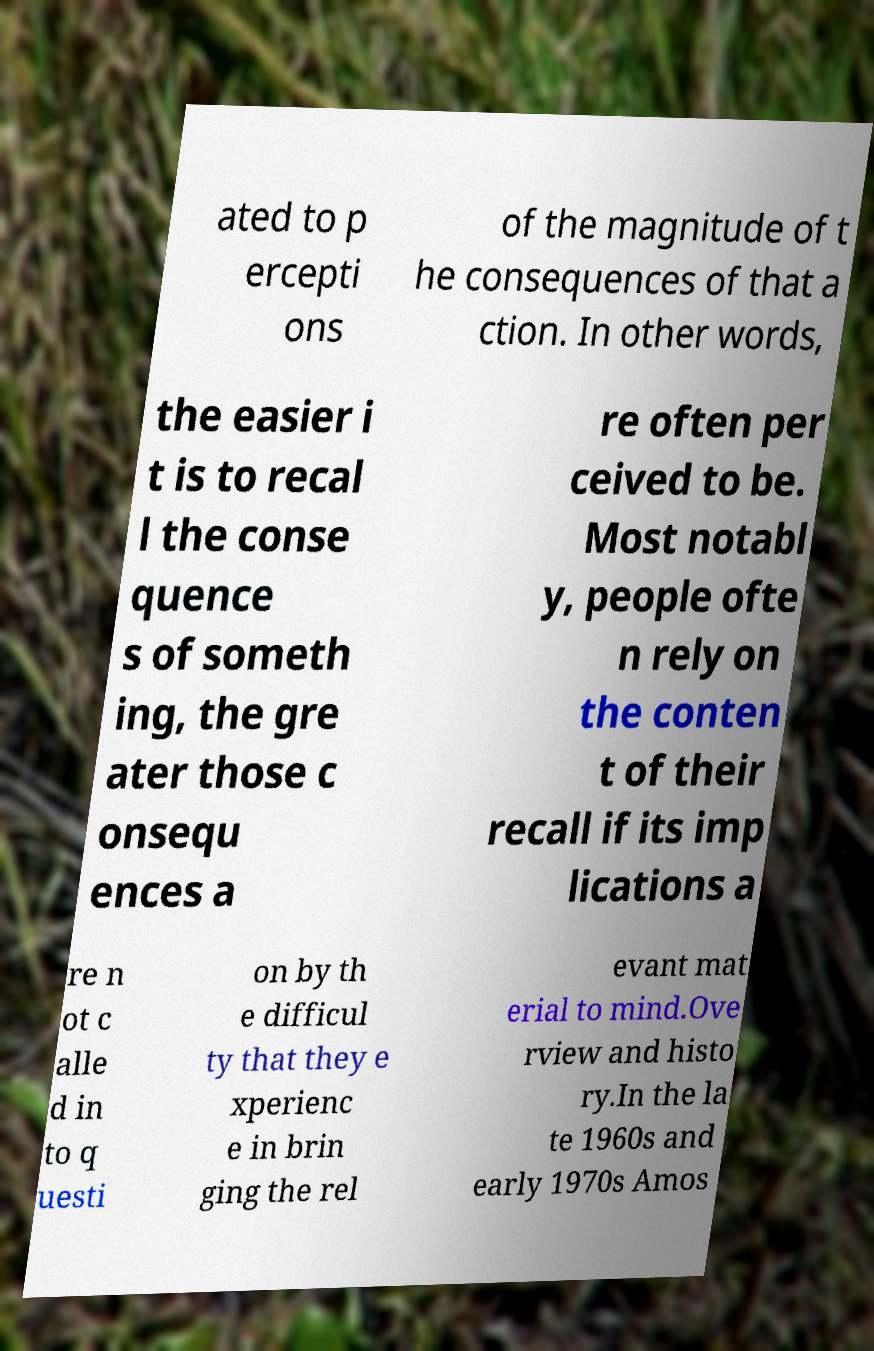Please identify and transcribe the text found in this image. ated to p ercepti ons of the magnitude of t he consequences of that a ction. In other words, the easier i t is to recal l the conse quence s of someth ing, the gre ater those c onsequ ences a re often per ceived to be. Most notabl y, people ofte n rely on the conten t of their recall if its imp lications a re n ot c alle d in to q uesti on by th e difficul ty that they e xperienc e in brin ging the rel evant mat erial to mind.Ove rview and histo ry.In the la te 1960s and early 1970s Amos 